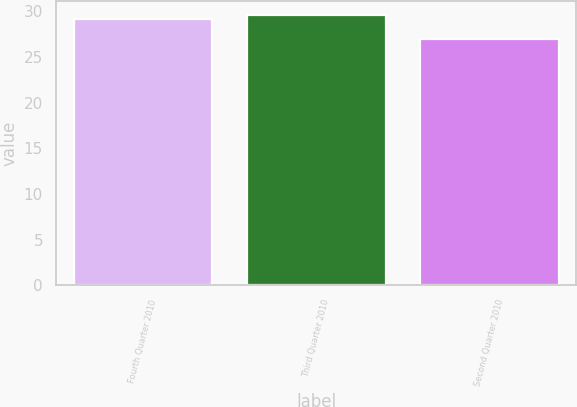Convert chart to OTSL. <chart><loc_0><loc_0><loc_500><loc_500><bar_chart><fcel>Fourth Quarter 2010<fcel>Third Quarter 2010<fcel>Second Quarter 2010<nl><fcel>29.1<fcel>29.6<fcel>26.9<nl></chart> 